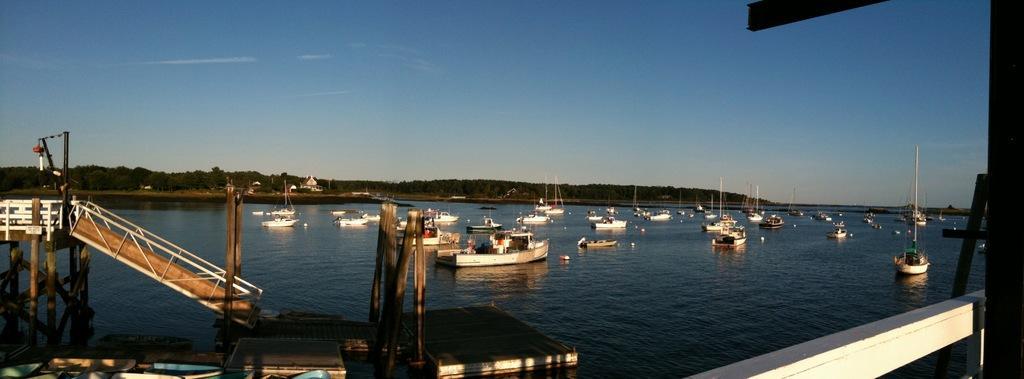In one or two sentences, can you explain what this image depicts? In the foreground of this image, there is the dock and many ships and boats on the water, trees, sky and the cloud. 